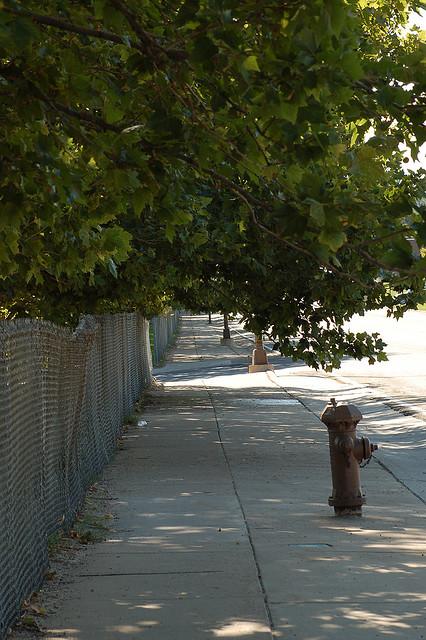Are there leaves on the ground? Yes, there are scattered leaves on the ground, which suggests that some leaves have fallen, possibly due to natural thinning or wind. 